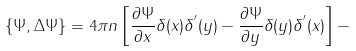<formula> <loc_0><loc_0><loc_500><loc_500>\{ \Psi , \Delta \Psi \} = 4 \pi n \left [ \frac { \partial \Psi } { \partial x } \delta ( x ) \delta ^ { ^ { \prime } } ( y ) - \frac { \partial \Psi } { \partial y } \delta ( y ) \delta ^ { ^ { \prime } } ( x ) \right ] -</formula> 